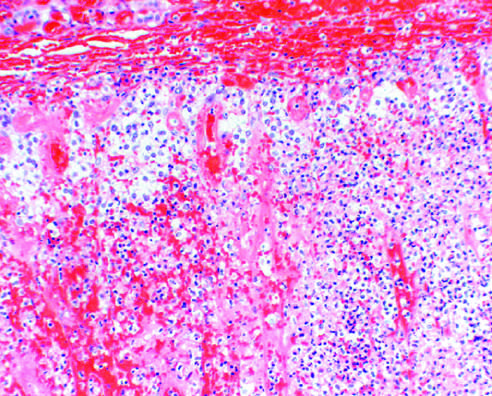what did bilateral adrenal hemorrhage in an infant with overwhelming sepsis result in?
Answer the question using a single word or phrase. Acute adrenal insufficiency 